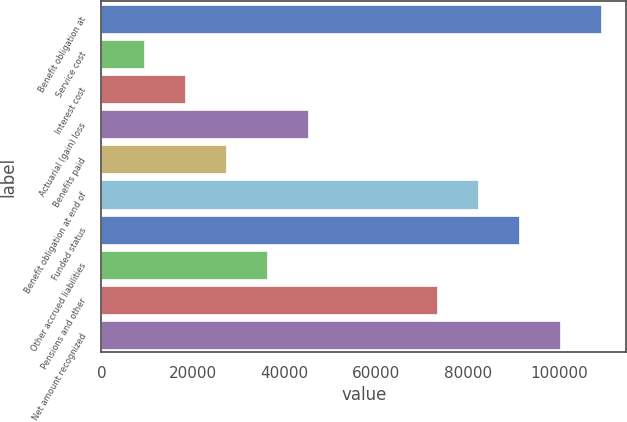Convert chart to OTSL. <chart><loc_0><loc_0><loc_500><loc_500><bar_chart><fcel>Benefit obligation at<fcel>Service cost<fcel>Interest cost<fcel>Actuarial (gain) loss<fcel>Benefits paid<fcel>Benefit obligation at end of<fcel>Funded status<fcel>Other accrued liabilities<fcel>Pensions and other<fcel>Net amount recognized<nl><fcel>109141<fcel>9370<fcel>18305<fcel>45110<fcel>27240<fcel>82336<fcel>91271<fcel>36175<fcel>73401<fcel>100206<nl></chart> 